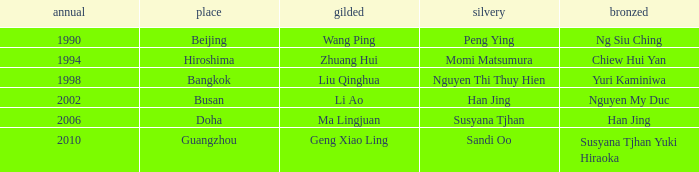What's the Bronze with the Year of 1998? Yuri Kaminiwa. 